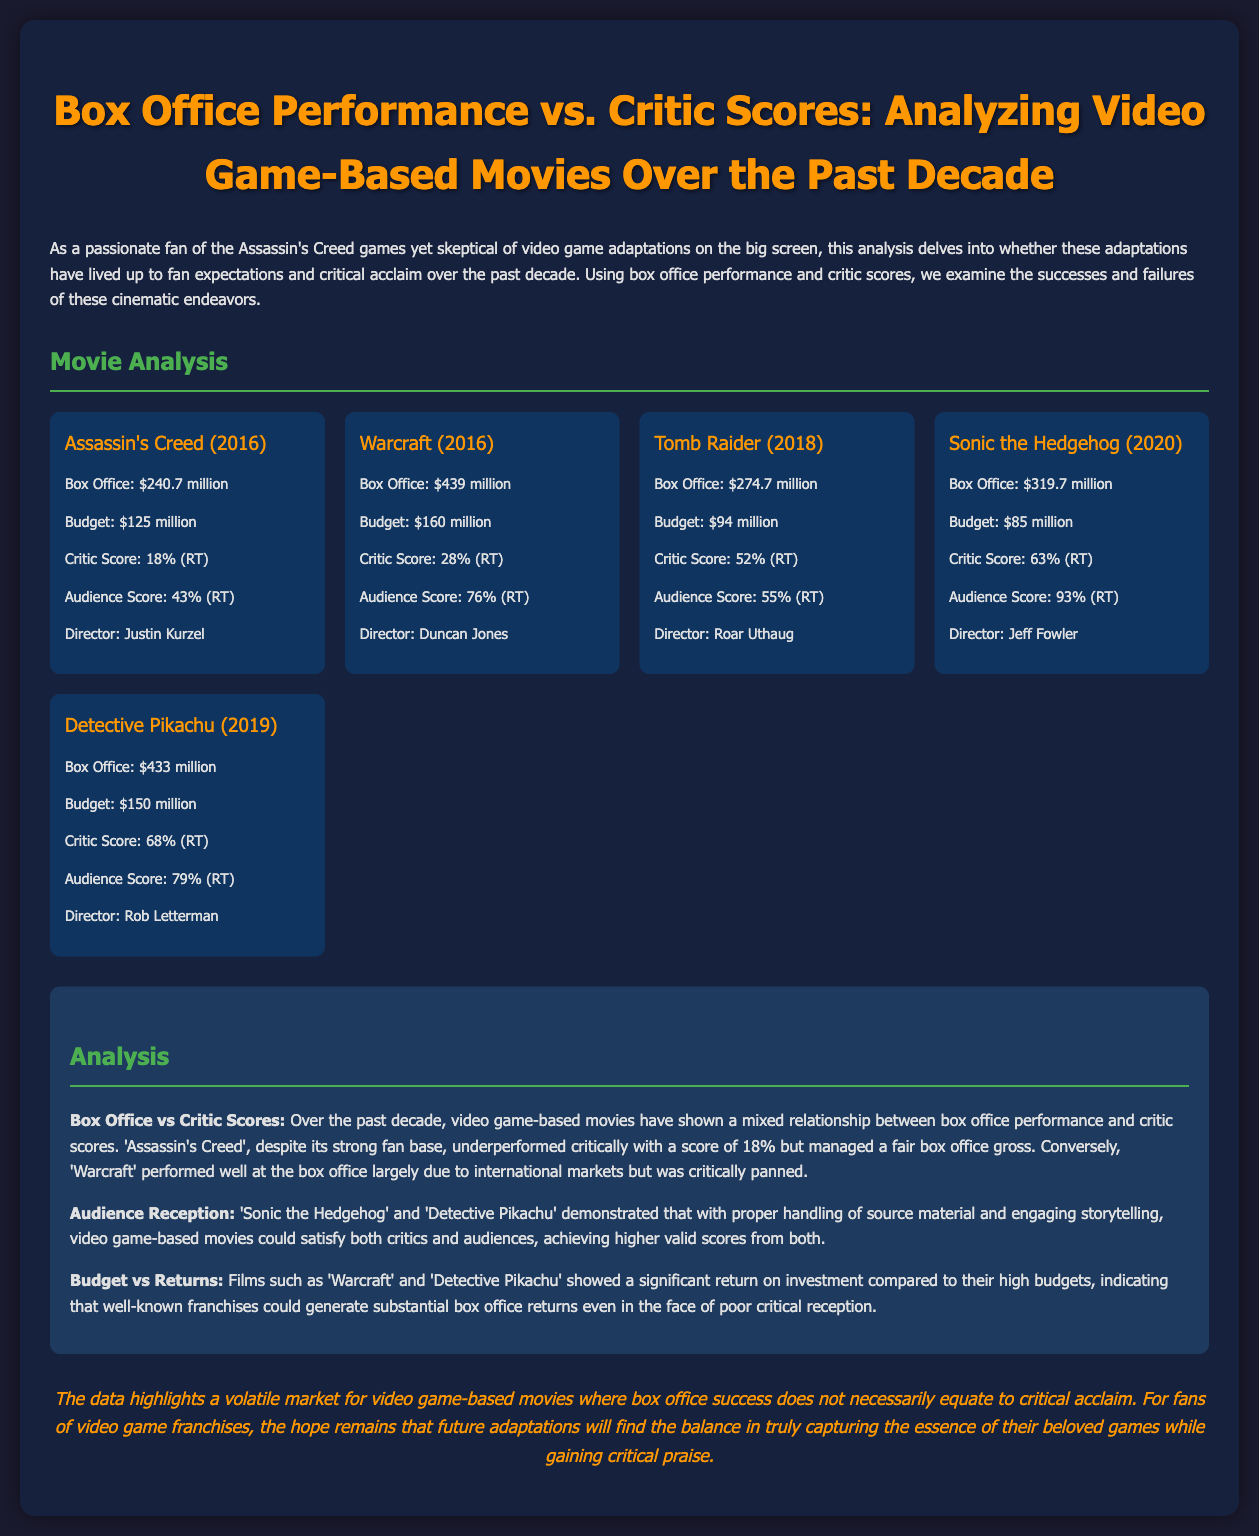What is the box office gross for Assassin's Creed? The box office gross for Assassin's Creed is listed in the movie analysis section as $240.7 million.
Answer: $240.7 million What is the critic score for Tomb Raider? The document states that the critic score for Tomb Raider is 52% according to Rotten Tomatoes (RT).
Answer: 52% Who directed Sonic the Hedgehog? The director of Sonic the Hedgehog is mentioned in the movie card as Jeff Fowler.
Answer: Jeff Fowler Which film had the highest critic score? The analysis shows that Detective Pikachu achieved the highest critic score of 68% among the listed films.
Answer: 68% What was the budget for Warcraft? The budget for Warcraft is recorded in the movie card as $160 million.
Answer: $160 million Which two films satisfied both critics and audiences? The analysis highlights Sonic the Hedgehog and Detective Pikachu as films that achieved higher scores from both critics and audiences.
Answer: Sonic the Hedgehog and Detective Pikachu What does the data highlight about video game-based movies? The conclusion summarizes that the data highlights a volatile market for video game-based movies, where box office success does not necessarily equate to critical acclaim.
Answer: Volatile market How much did Detective Pikachu earn at the box office? The document indicates that Detective Pikachu grossed $433 million at the box office.
Answer: $433 million What trend is observed in the relationship between budget and returns? The analysis mentions that films like Warcraft and Detective Pikachu show significant returns compared to their high budgets, indicating that well-known franchises could generate substantial box office returns.
Answer: Significant returns 